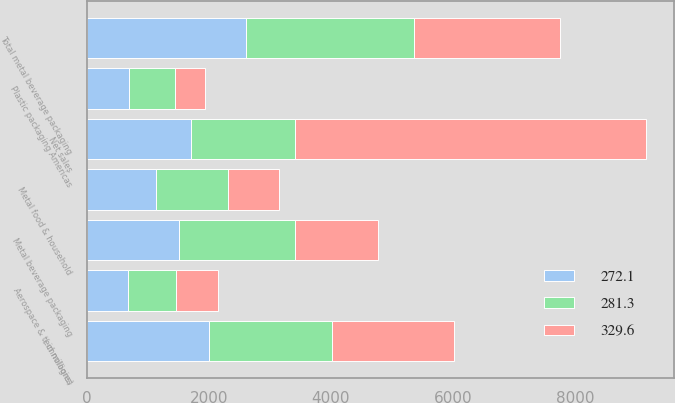<chart> <loc_0><loc_0><loc_500><loc_500><stacked_bar_chart><ecel><fcel>( in millions)<fcel>Metal beverage packaging<fcel>Total metal beverage packaging<fcel>Metal food & household<fcel>Plastic packaging Americas<fcel>Aerospace & technologies<fcel>Net sales<nl><fcel>281.3<fcel>2007<fcel>1902.2<fcel>2763.9<fcel>1183.4<fcel>752.4<fcel>787.8<fcel>1707.35<nl><fcel>272.1<fcel>2006<fcel>1512.5<fcel>2604.4<fcel>1138.7<fcel>693.6<fcel>672.3<fcel>1707.35<nl><fcel>329.6<fcel>2005<fcel>1354.5<fcel>2390.4<fcel>824<fcel>487.5<fcel>694.8<fcel>5751.2<nl></chart> 